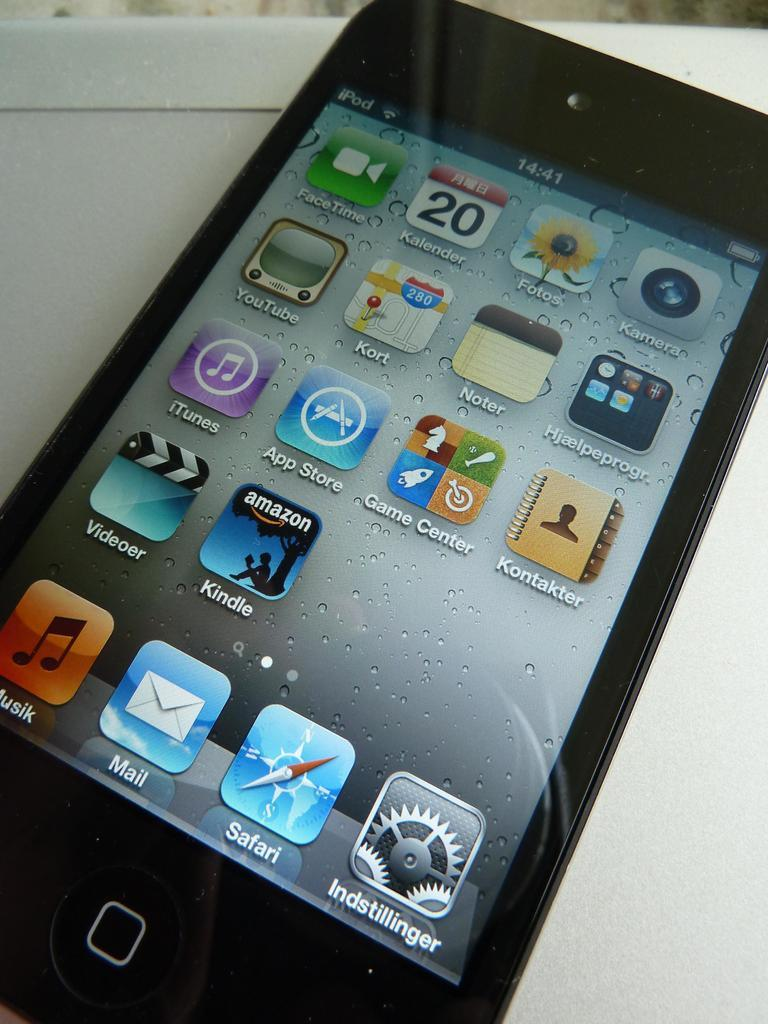<image>
Describe the image concisely. a phone with a Game Center app on it 